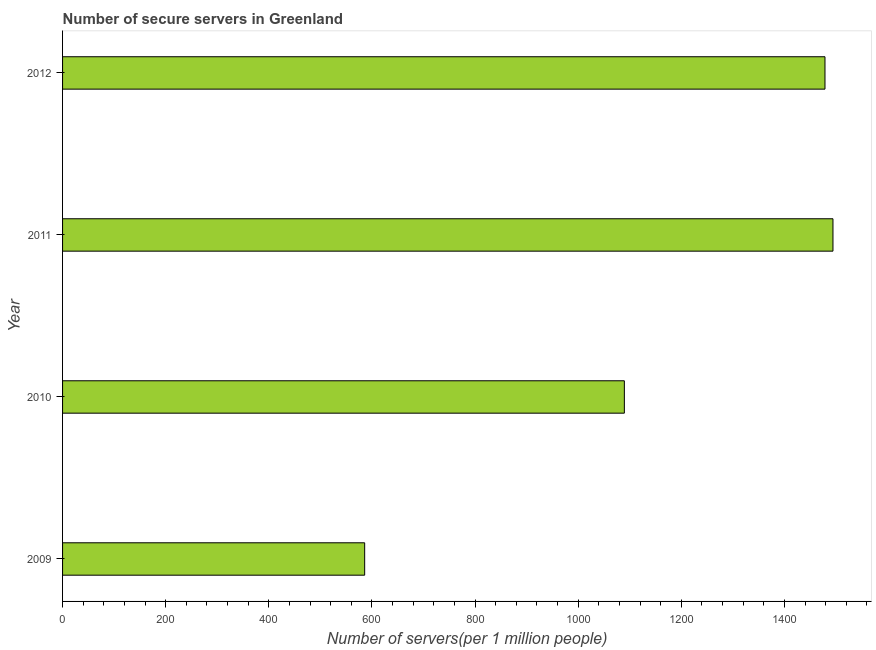Does the graph contain grids?
Provide a succinct answer. No. What is the title of the graph?
Your answer should be compact. Number of secure servers in Greenland. What is the label or title of the X-axis?
Make the answer very short. Number of servers(per 1 million people). What is the label or title of the Y-axis?
Offer a very short reply. Year. What is the number of secure internet servers in 2010?
Provide a succinct answer. 1089.54. Across all years, what is the maximum number of secure internet servers?
Keep it short and to the point. 1494.11. Across all years, what is the minimum number of secure internet servers?
Make the answer very short. 585.91. In which year was the number of secure internet servers minimum?
Give a very brief answer. 2009. What is the sum of the number of secure internet servers?
Offer a very short reply. 4648.17. What is the difference between the number of secure internet servers in 2010 and 2012?
Offer a very short reply. -389.08. What is the average number of secure internet servers per year?
Make the answer very short. 1162.04. What is the median number of secure internet servers?
Make the answer very short. 1284.07. What is the ratio of the number of secure internet servers in 2009 to that in 2010?
Provide a succinct answer. 0.54. Is the difference between the number of secure internet servers in 2009 and 2011 greater than the difference between any two years?
Keep it short and to the point. Yes. What is the difference between the highest and the second highest number of secure internet servers?
Your answer should be very brief. 15.5. What is the difference between the highest and the lowest number of secure internet servers?
Keep it short and to the point. 908.21. In how many years, is the number of secure internet servers greater than the average number of secure internet servers taken over all years?
Your response must be concise. 2. Are all the bars in the graph horizontal?
Provide a succinct answer. Yes. How many years are there in the graph?
Your answer should be compact. 4. What is the difference between two consecutive major ticks on the X-axis?
Offer a very short reply. 200. Are the values on the major ticks of X-axis written in scientific E-notation?
Give a very brief answer. No. What is the Number of servers(per 1 million people) of 2009?
Make the answer very short. 585.91. What is the Number of servers(per 1 million people) in 2010?
Keep it short and to the point. 1089.54. What is the Number of servers(per 1 million people) of 2011?
Offer a very short reply. 1494.11. What is the Number of servers(per 1 million people) in 2012?
Offer a very short reply. 1478.61. What is the difference between the Number of servers(per 1 million people) in 2009 and 2010?
Offer a terse response. -503.63. What is the difference between the Number of servers(per 1 million people) in 2009 and 2011?
Your response must be concise. -908.21. What is the difference between the Number of servers(per 1 million people) in 2009 and 2012?
Give a very brief answer. -892.71. What is the difference between the Number of servers(per 1 million people) in 2010 and 2011?
Your answer should be very brief. -404.58. What is the difference between the Number of servers(per 1 million people) in 2010 and 2012?
Provide a succinct answer. -389.08. What is the difference between the Number of servers(per 1 million people) in 2011 and 2012?
Offer a very short reply. 15.5. What is the ratio of the Number of servers(per 1 million people) in 2009 to that in 2010?
Make the answer very short. 0.54. What is the ratio of the Number of servers(per 1 million people) in 2009 to that in 2011?
Your response must be concise. 0.39. What is the ratio of the Number of servers(per 1 million people) in 2009 to that in 2012?
Your response must be concise. 0.4. What is the ratio of the Number of servers(per 1 million people) in 2010 to that in 2011?
Keep it short and to the point. 0.73. What is the ratio of the Number of servers(per 1 million people) in 2010 to that in 2012?
Provide a short and direct response. 0.74. 